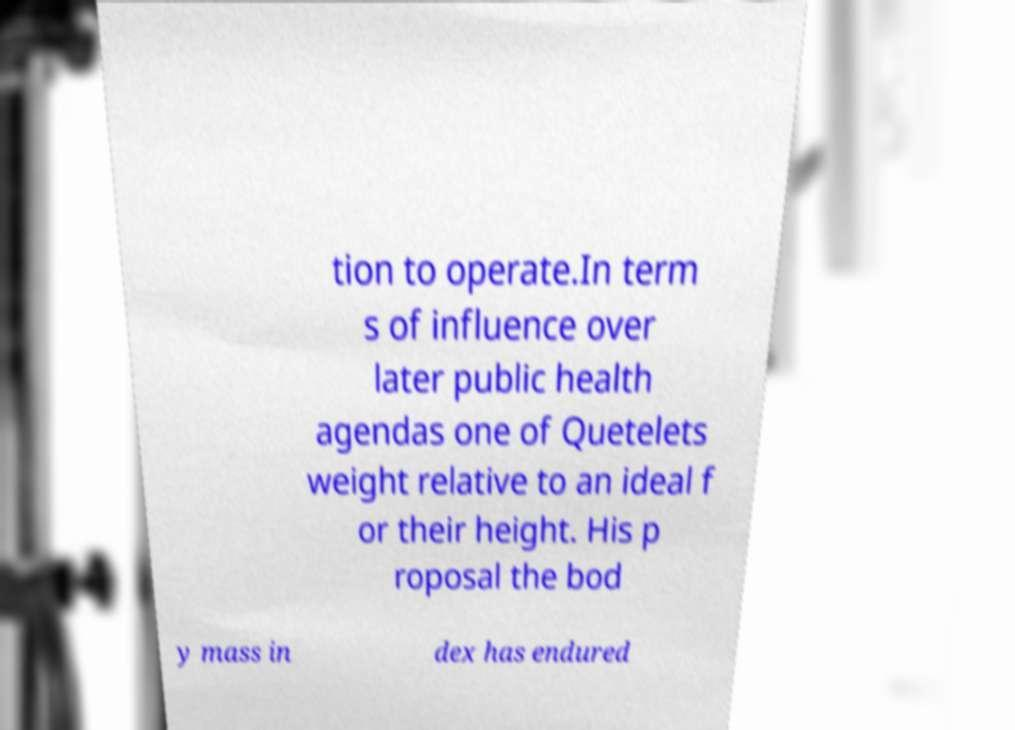Could you extract and type out the text from this image? tion to operate.In term s of influence over later public health agendas one of Quetelets weight relative to an ideal f or their height. His p roposal the bod y mass in dex has endured 